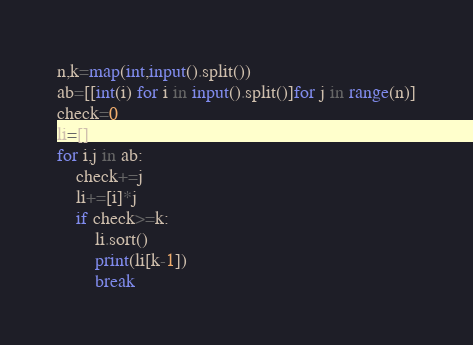<code> <loc_0><loc_0><loc_500><loc_500><_Python_>n,k=map(int,input().split())
ab=[[int(i) for i in input().split()]for j in range(n)]
check=0
li=[]
for i,j in ab:
    check+=j
    li+=[i]*j
    if check>=k:
        li.sort()
        print(li[k-1])
        break</code> 